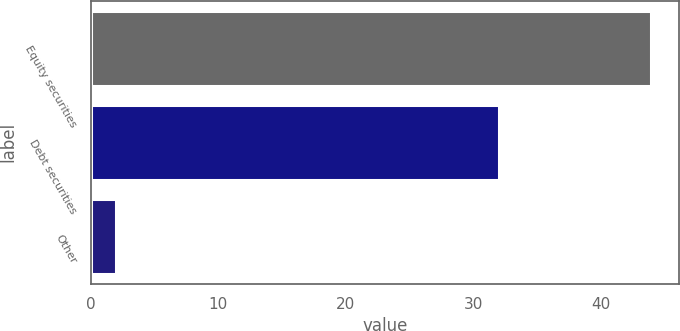<chart> <loc_0><loc_0><loc_500><loc_500><bar_chart><fcel>Equity securities<fcel>Debt securities<fcel>Other<nl><fcel>44<fcel>32<fcel>2<nl></chart> 